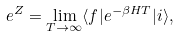Convert formula to latex. <formula><loc_0><loc_0><loc_500><loc_500>e ^ { Z } = \lim _ { T \to \infty } \langle f | e ^ { - \beta H T } | i \rangle ,</formula> 